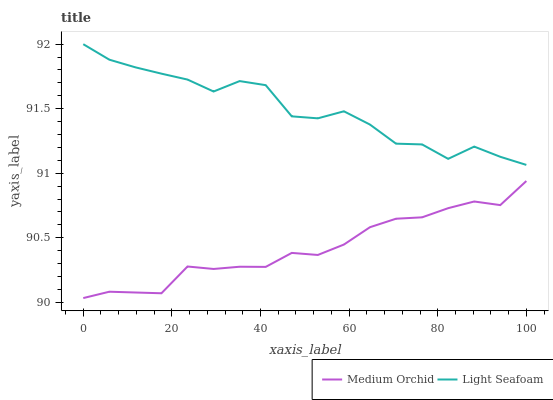Does Medium Orchid have the minimum area under the curve?
Answer yes or no. Yes. Does Light Seafoam have the maximum area under the curve?
Answer yes or no. Yes. Does Light Seafoam have the minimum area under the curve?
Answer yes or no. No. Is Medium Orchid the smoothest?
Answer yes or no. Yes. Is Light Seafoam the roughest?
Answer yes or no. Yes. Is Light Seafoam the smoothest?
Answer yes or no. No. Does Medium Orchid have the lowest value?
Answer yes or no. Yes. Does Light Seafoam have the lowest value?
Answer yes or no. No. Does Light Seafoam have the highest value?
Answer yes or no. Yes. Is Medium Orchid less than Light Seafoam?
Answer yes or no. Yes. Is Light Seafoam greater than Medium Orchid?
Answer yes or no. Yes. Does Medium Orchid intersect Light Seafoam?
Answer yes or no. No. 